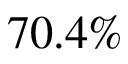Convert formula to latex. <formula><loc_0><loc_0><loc_500><loc_500>7 0 . 4 \%</formula> 